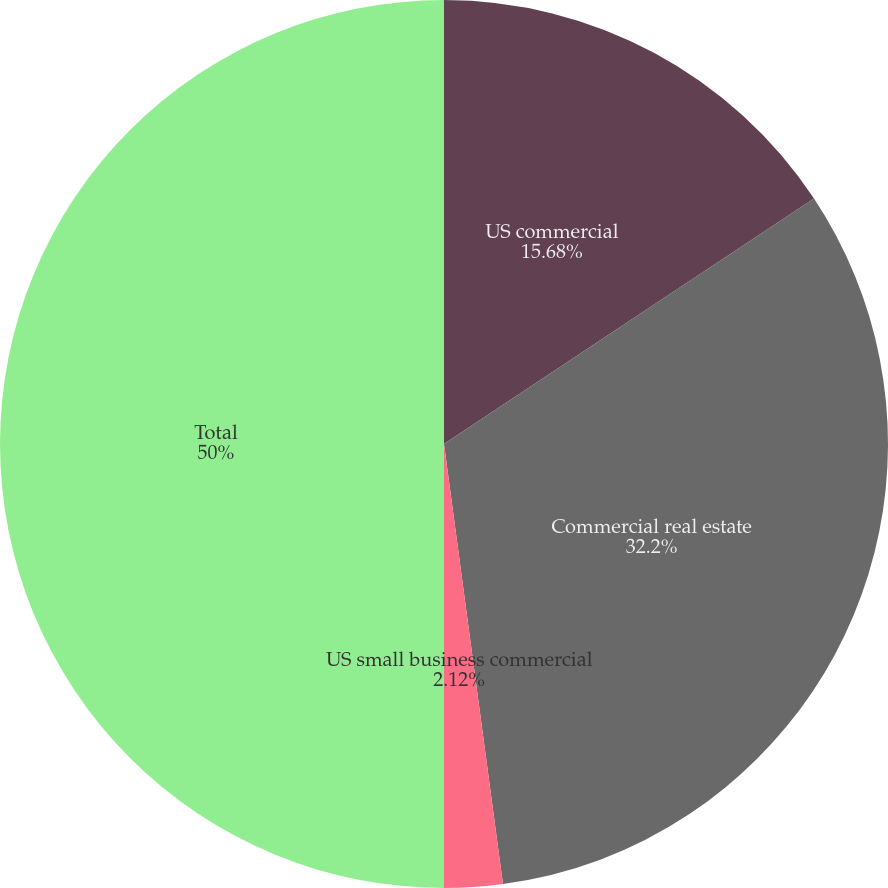<chart> <loc_0><loc_0><loc_500><loc_500><pie_chart><fcel>US commercial<fcel>Commercial real estate<fcel>US small business commercial<fcel>Total<nl><fcel>15.68%<fcel>32.2%<fcel>2.12%<fcel>50.0%<nl></chart> 